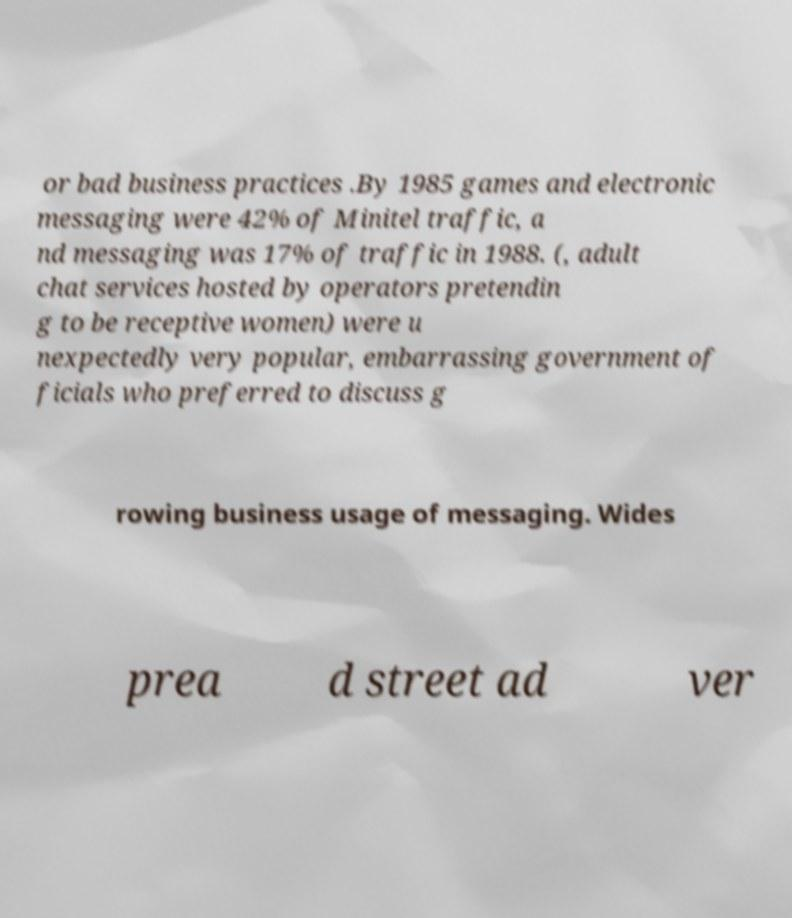Can you read and provide the text displayed in the image?This photo seems to have some interesting text. Can you extract and type it out for me? or bad business practices .By 1985 games and electronic messaging were 42% of Minitel traffic, a nd messaging was 17% of traffic in 1988. (, adult chat services hosted by operators pretendin g to be receptive women) were u nexpectedly very popular, embarrassing government of ficials who preferred to discuss g rowing business usage of messaging. Wides prea d street ad ver 